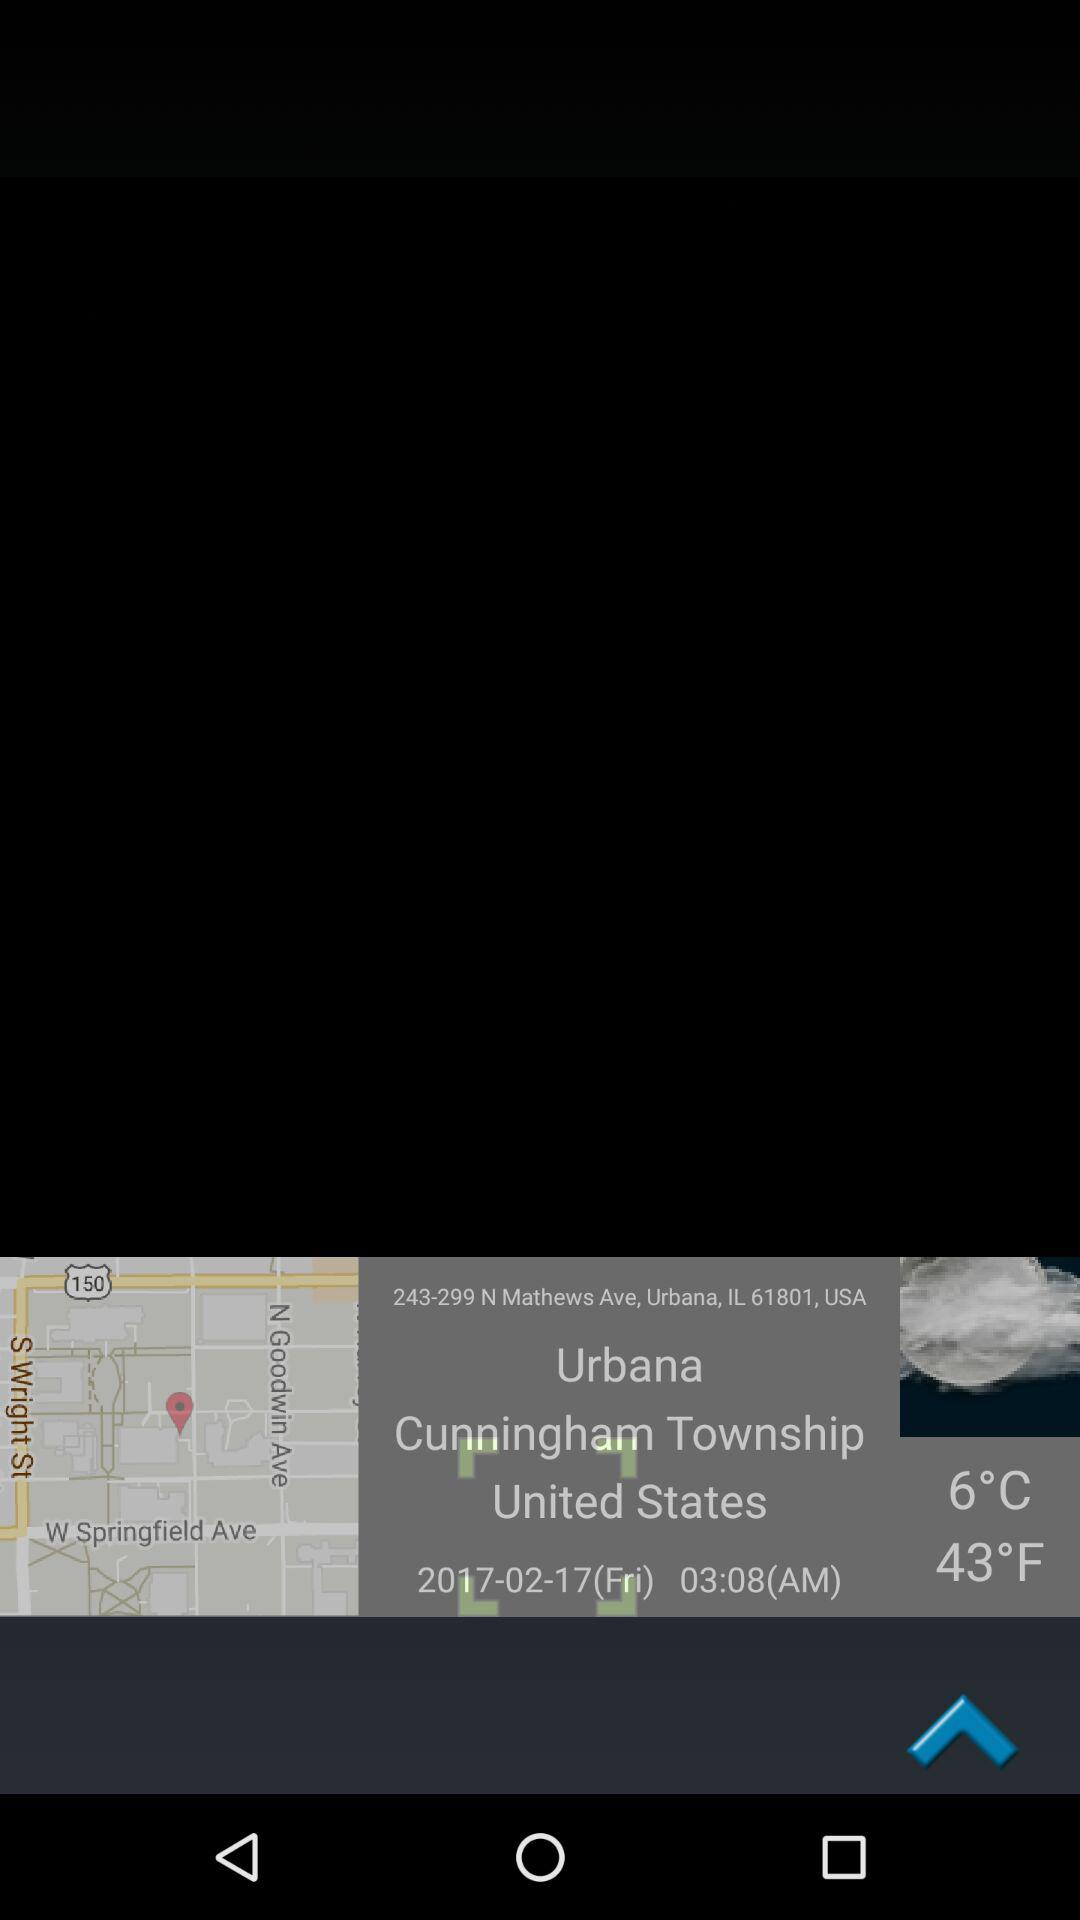What is the given location? The given location is 243-299 N Mathews Ave, Urbana, IL 61801, USA. 